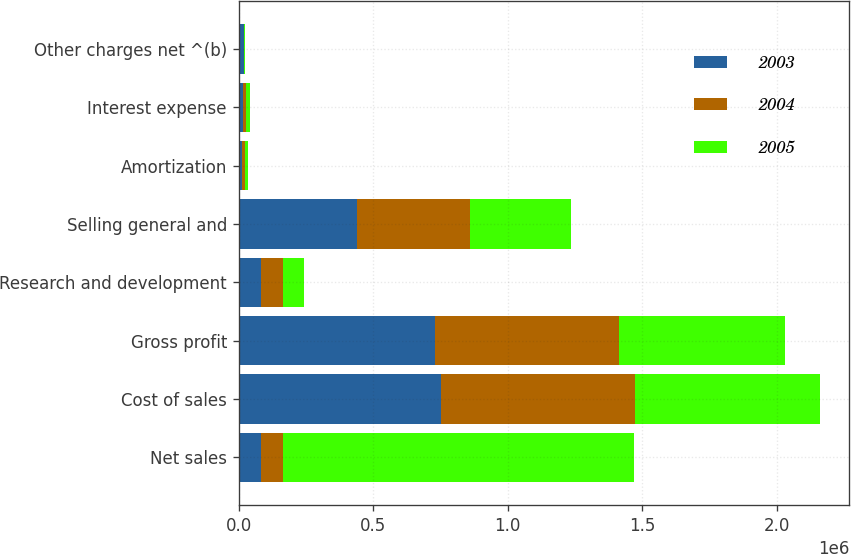Convert chart to OTSL. <chart><loc_0><loc_0><loc_500><loc_500><stacked_bar_chart><ecel><fcel>Net sales<fcel>Cost of sales<fcel>Gross profit<fcel>Research and development<fcel>Selling general and<fcel>Amortization<fcel>Interest expense<fcel>Other charges net ^(b)<nl><fcel>2003<fcel>82555<fcel>752153<fcel>730319<fcel>81893<fcel>441702<fcel>11436<fcel>14880<fcel>20224<nl><fcel>2004<fcel>82555<fcel>722047<fcel>682407<fcel>83217<fcel>419780<fcel>12256<fcel>12888<fcel>42<nl><fcel>2005<fcel>1.30443e+06<fcel>686255<fcel>618176<fcel>78003<fcel>372822<fcel>11724<fcel>14153<fcel>4563<nl></chart> 